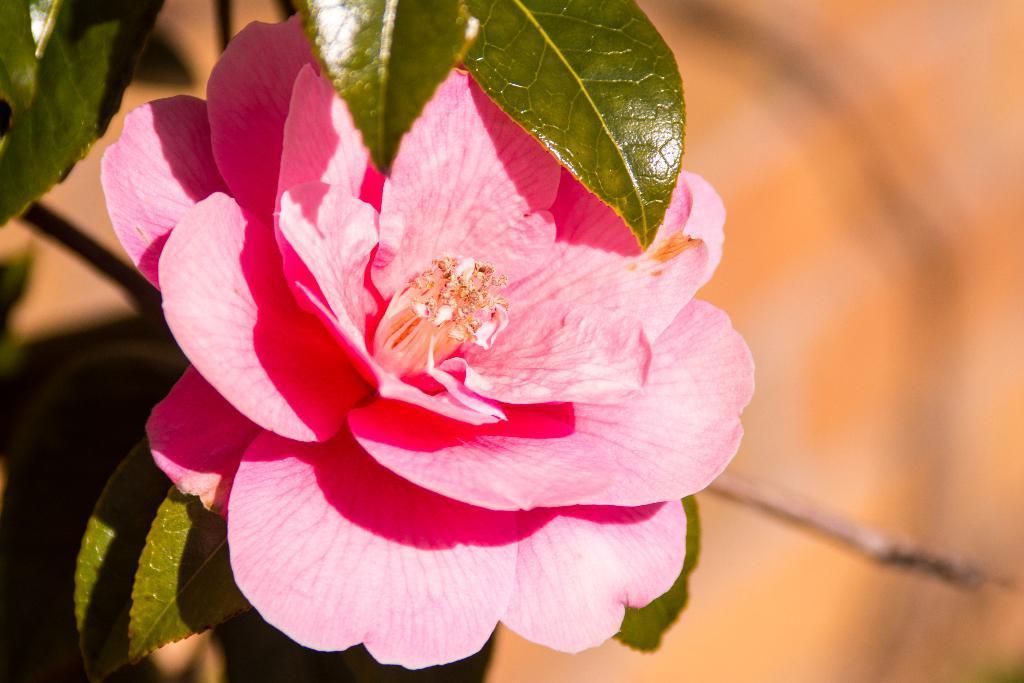Please provide a concise description of this image. In this image in the foreground I can see a flower and some leaves and in the background I can see the blur. 